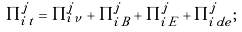Convert formula to latex. <formula><loc_0><loc_0><loc_500><loc_500>\Pi _ { i \, t } ^ { j } = \Pi _ { i \, \nu } ^ { j } + \Pi _ { i \, B } ^ { j } + \Pi _ { i \, E } ^ { j } + \Pi _ { i \, d e } ^ { j } ;</formula> 